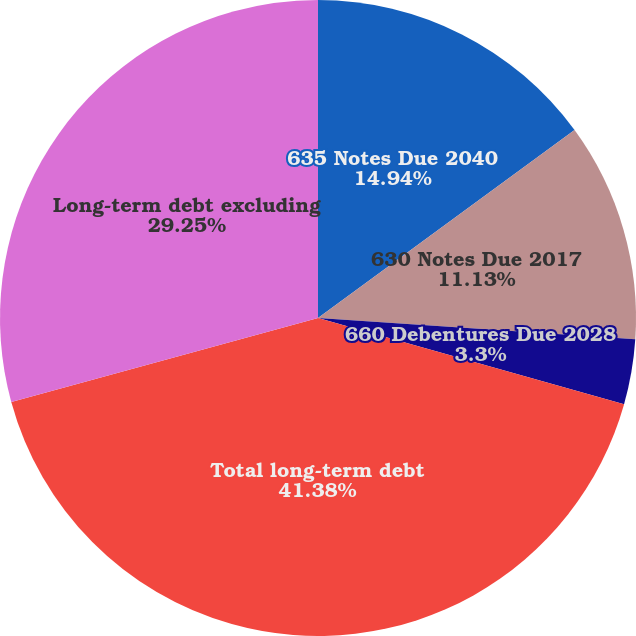<chart> <loc_0><loc_0><loc_500><loc_500><pie_chart><fcel>635 Notes Due 2040<fcel>630 Notes Due 2017<fcel>660 Debentures Due 2028<fcel>Total long-term debt<fcel>Long-term debt excluding<nl><fcel>14.94%<fcel>11.13%<fcel>3.3%<fcel>41.38%<fcel>29.25%<nl></chart> 